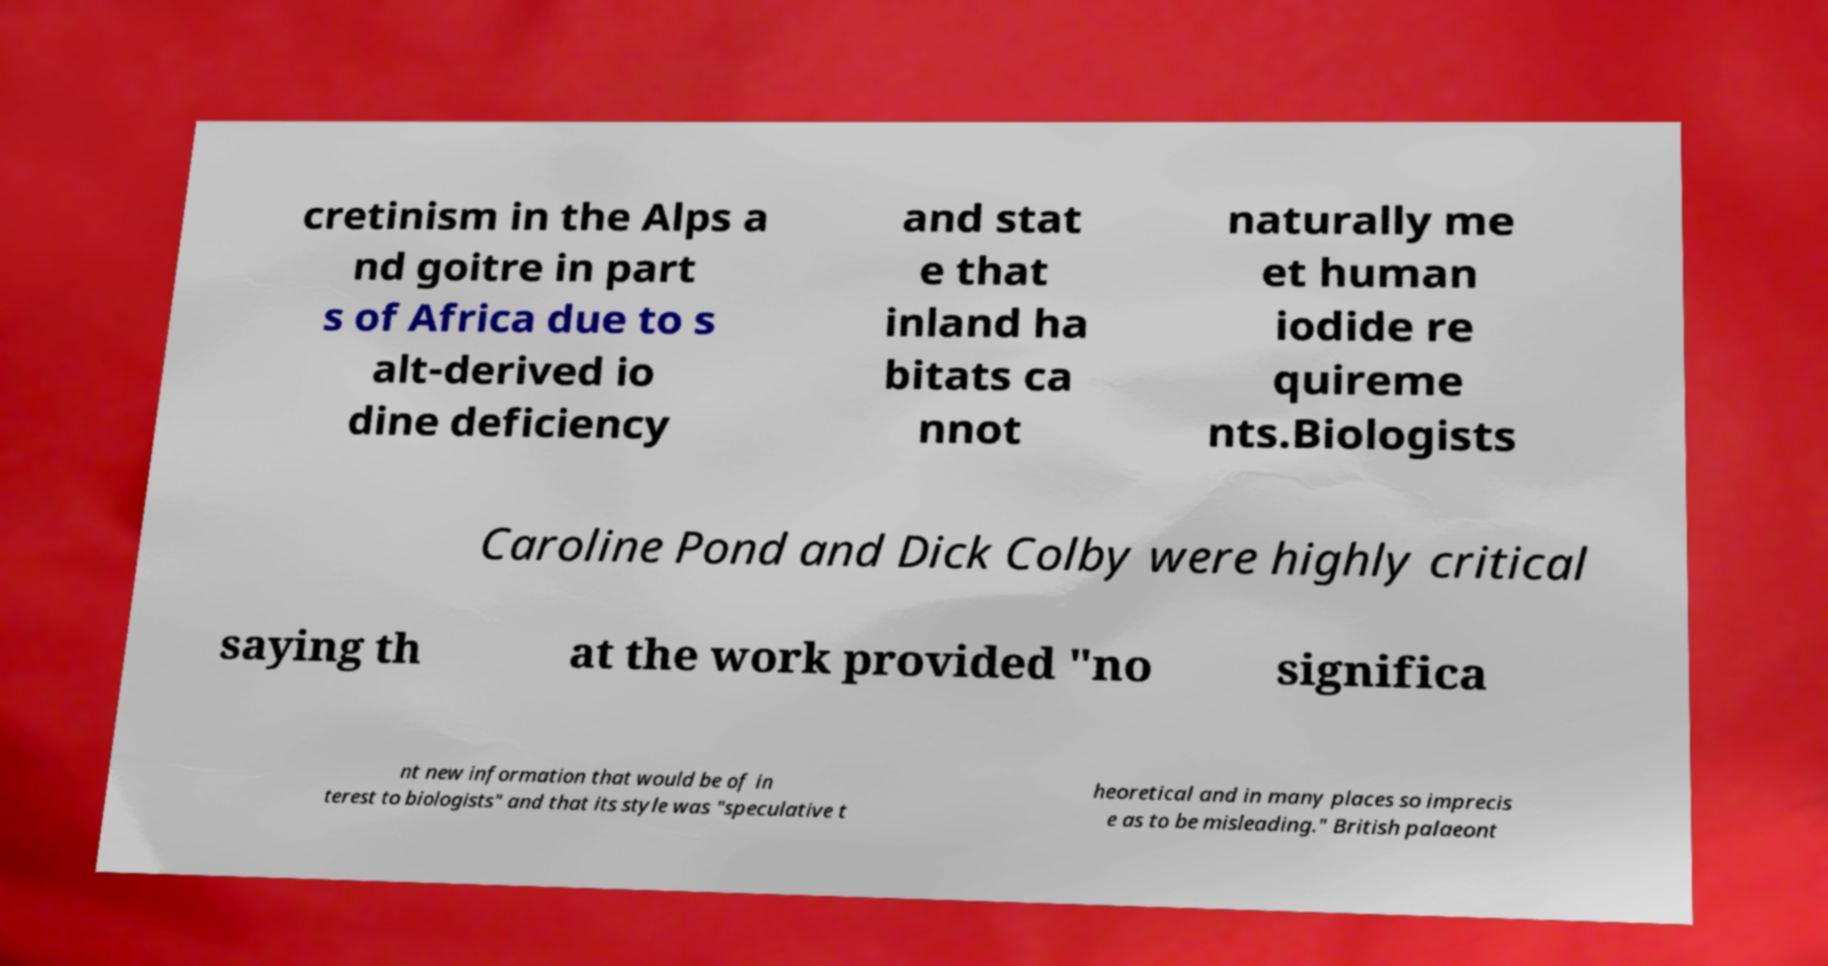Could you extract and type out the text from this image? cretinism in the Alps a nd goitre in part s of Africa due to s alt-derived io dine deficiency and stat e that inland ha bitats ca nnot naturally me et human iodide re quireme nts.Biologists Caroline Pond and Dick Colby were highly critical saying th at the work provided "no significa nt new information that would be of in terest to biologists" and that its style was "speculative t heoretical and in many places so imprecis e as to be misleading." British palaeont 